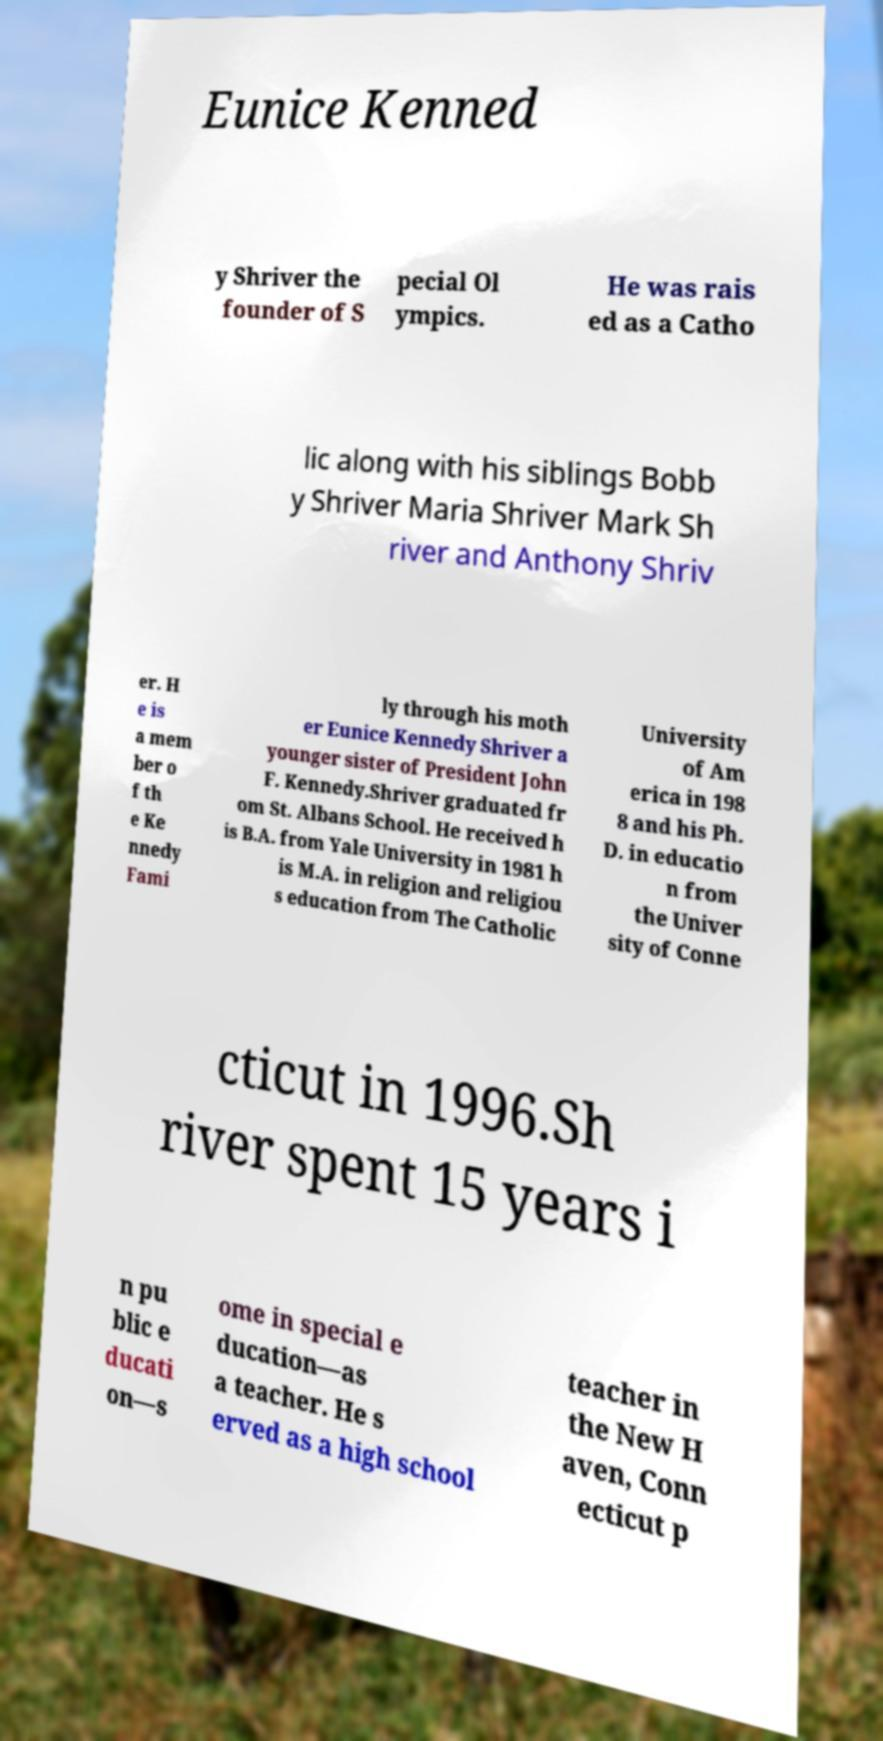Can you read and provide the text displayed in the image?This photo seems to have some interesting text. Can you extract and type it out for me? Eunice Kenned y Shriver the founder of S pecial Ol ympics. He was rais ed as a Catho lic along with his siblings Bobb y Shriver Maria Shriver Mark Sh river and Anthony Shriv er. H e is a mem ber o f th e Ke nnedy Fami ly through his moth er Eunice Kennedy Shriver a younger sister of President John F. Kennedy.Shriver graduated fr om St. Albans School. He received h is B.A. from Yale University in 1981 h is M.A. in religion and religiou s education from The Catholic University of Am erica in 198 8 and his Ph. D. in educatio n from the Univer sity of Conne cticut in 1996.Sh river spent 15 years i n pu blic e ducati on—s ome in special e ducation—as a teacher. He s erved as a high school teacher in the New H aven, Conn ecticut p 